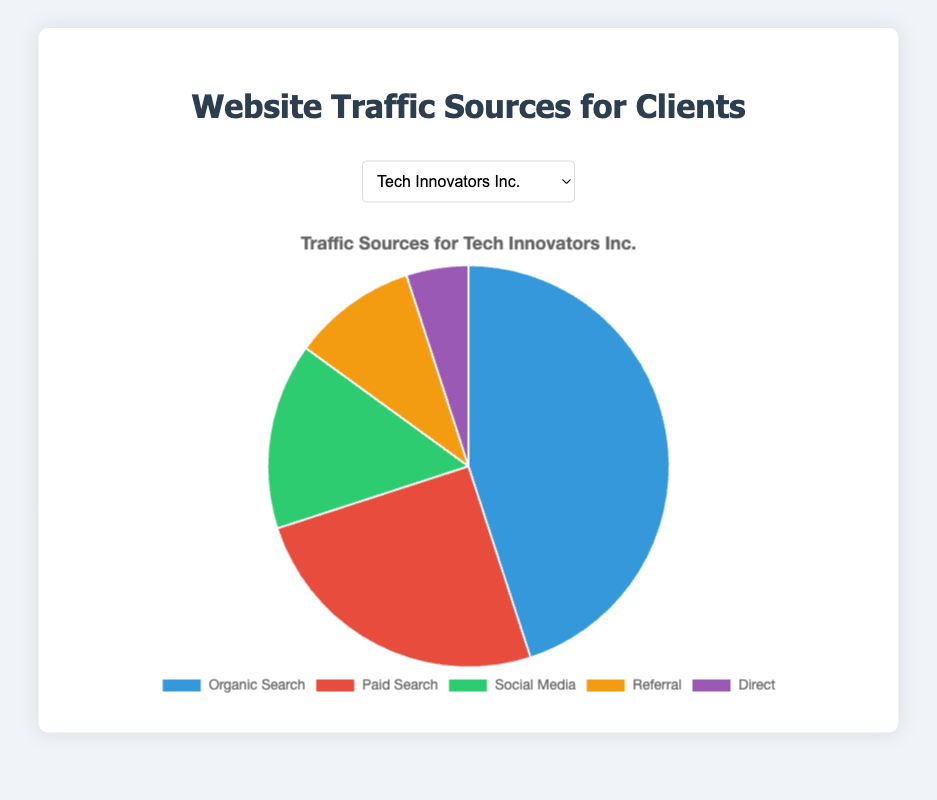Which traffic source contributes the most traffic for Tech Innovators Inc.? The chart shows that Organic Search has the largest segment in the pie chart for Tech Innovators Inc. with 45%.
Answer: Organic Search What is the combined traffic percentage of Social Media and Referral for HealthPlus Clinics? Social Media contributes 25% and Referral contributes 15%. Adding these together gives 25% + 15% = 40%.
Answer: 40% How much more traffic does Organic Search generate compared to Direct traffic for EcoLiving Supplies? Organic Search generates 50% and Direct generates 10%. The difference is 50% - 10% = 40%.
Answer: 40% What are the smallest and largest traffic sources for Fashion Forward? The smallest sources are Referral and Direct, both at 5%, and the largest source is Organic Search at 40%.
Answer: Referral/Direct and Organic Search If you sum all traffic percentages for Paid Search and Social Media for Urban Eats Restaurants, what do you get? Paid Search is 15% and Social Media is 25%. The sum is 15% + 25% = 40%.
Answer: 40% Between which two sources is traffic nearly equal for Urban Eats Restaurants? Referral and Social Media both contribute equal traffic of 15%.
Answer: Referral and Social Media Which client has the highest percentage of traffic from Organic Search? EcoLiving Supplies shows the highest traffic from Organic Search with 50%.
Answer: EcoLiving Supplies How much traffic does Referral generate compared to Direct for Tech Innovators Inc.? Referral generates 10% and Direct generates 5%. Referral is twice the amount of Direct.
Answer: Twice Which source has the second-highest percentage of traffic for Fashion Forward? Paid Search is second-highest for Fashion Forward at 30%.
Answer: Paid Search 